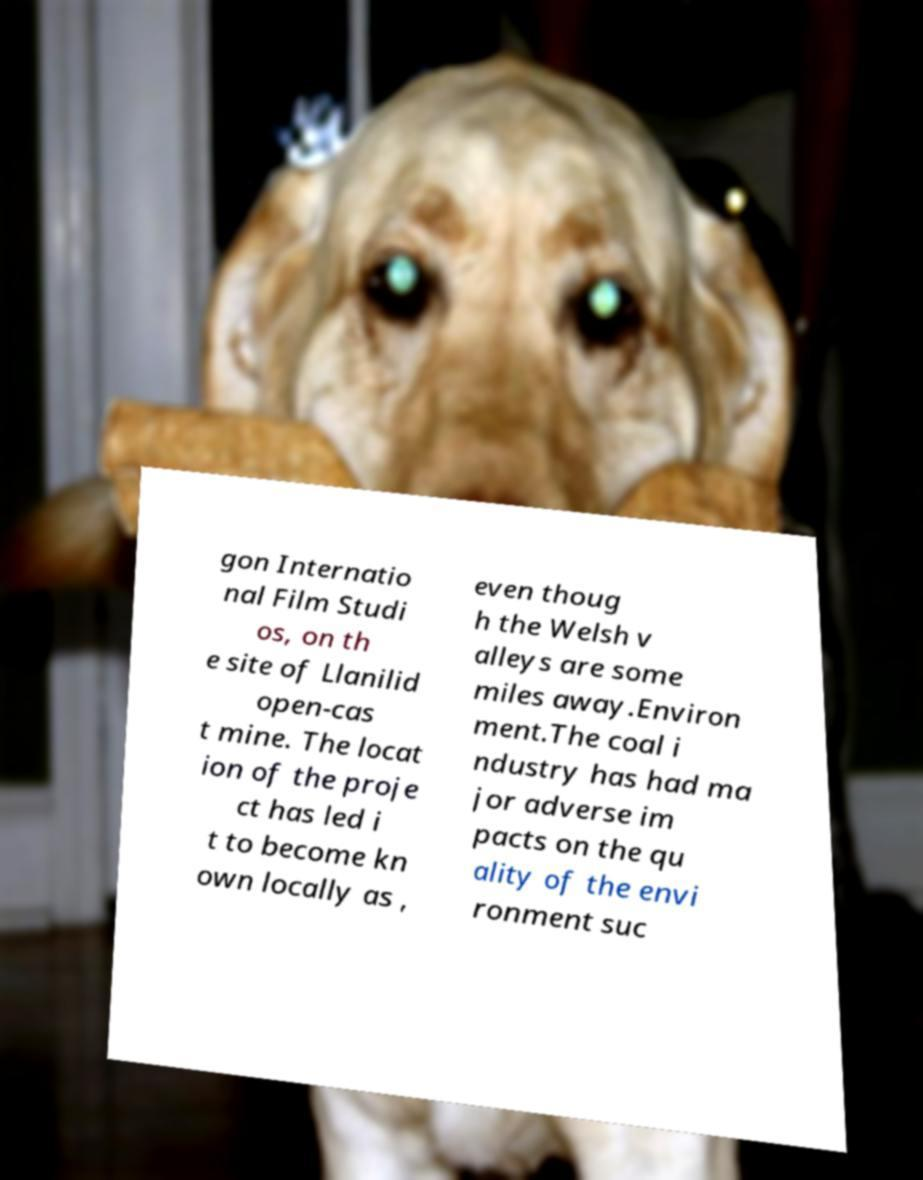Please identify and transcribe the text found in this image. gon Internatio nal Film Studi os, on th e site of Llanilid open-cas t mine. The locat ion of the proje ct has led i t to become kn own locally as , even thoug h the Welsh v alleys are some miles away.Environ ment.The coal i ndustry has had ma jor adverse im pacts on the qu ality of the envi ronment suc 